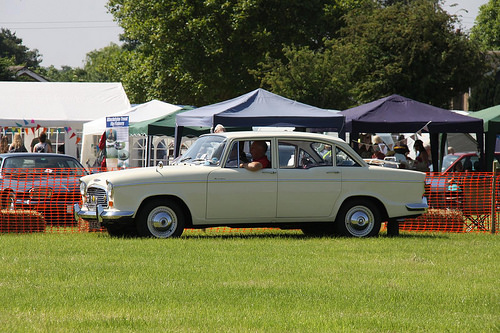<image>
Can you confirm if the car is in front of the lawn? No. The car is not in front of the lawn. The spatial positioning shows a different relationship between these objects. 